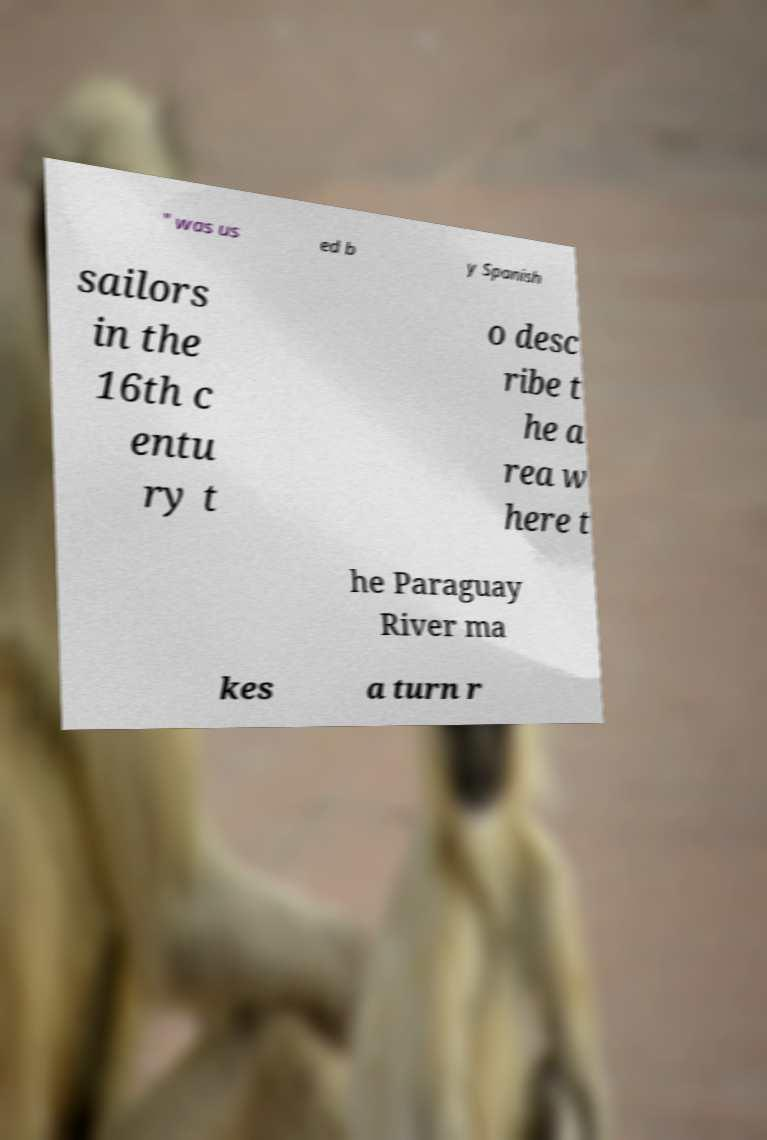What messages or text are displayed in this image? I need them in a readable, typed format. " was us ed b y Spanish sailors in the 16th c entu ry t o desc ribe t he a rea w here t he Paraguay River ma kes a turn r 